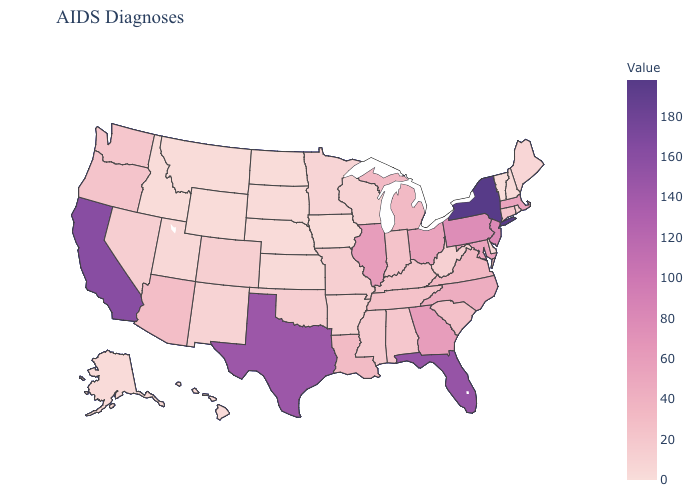Among the states that border Alabama , which have the lowest value?
Write a very short answer. Mississippi. Which states have the highest value in the USA?
Concise answer only. New York. Does Oklahoma have a higher value than North Carolina?
Concise answer only. No. Does Wyoming have the highest value in the West?
Answer briefly. No. Does Nevada have the highest value in the USA?
Write a very short answer. No. Among the states that border Nebraska , which have the highest value?
Answer briefly. Colorado, Missouri. 